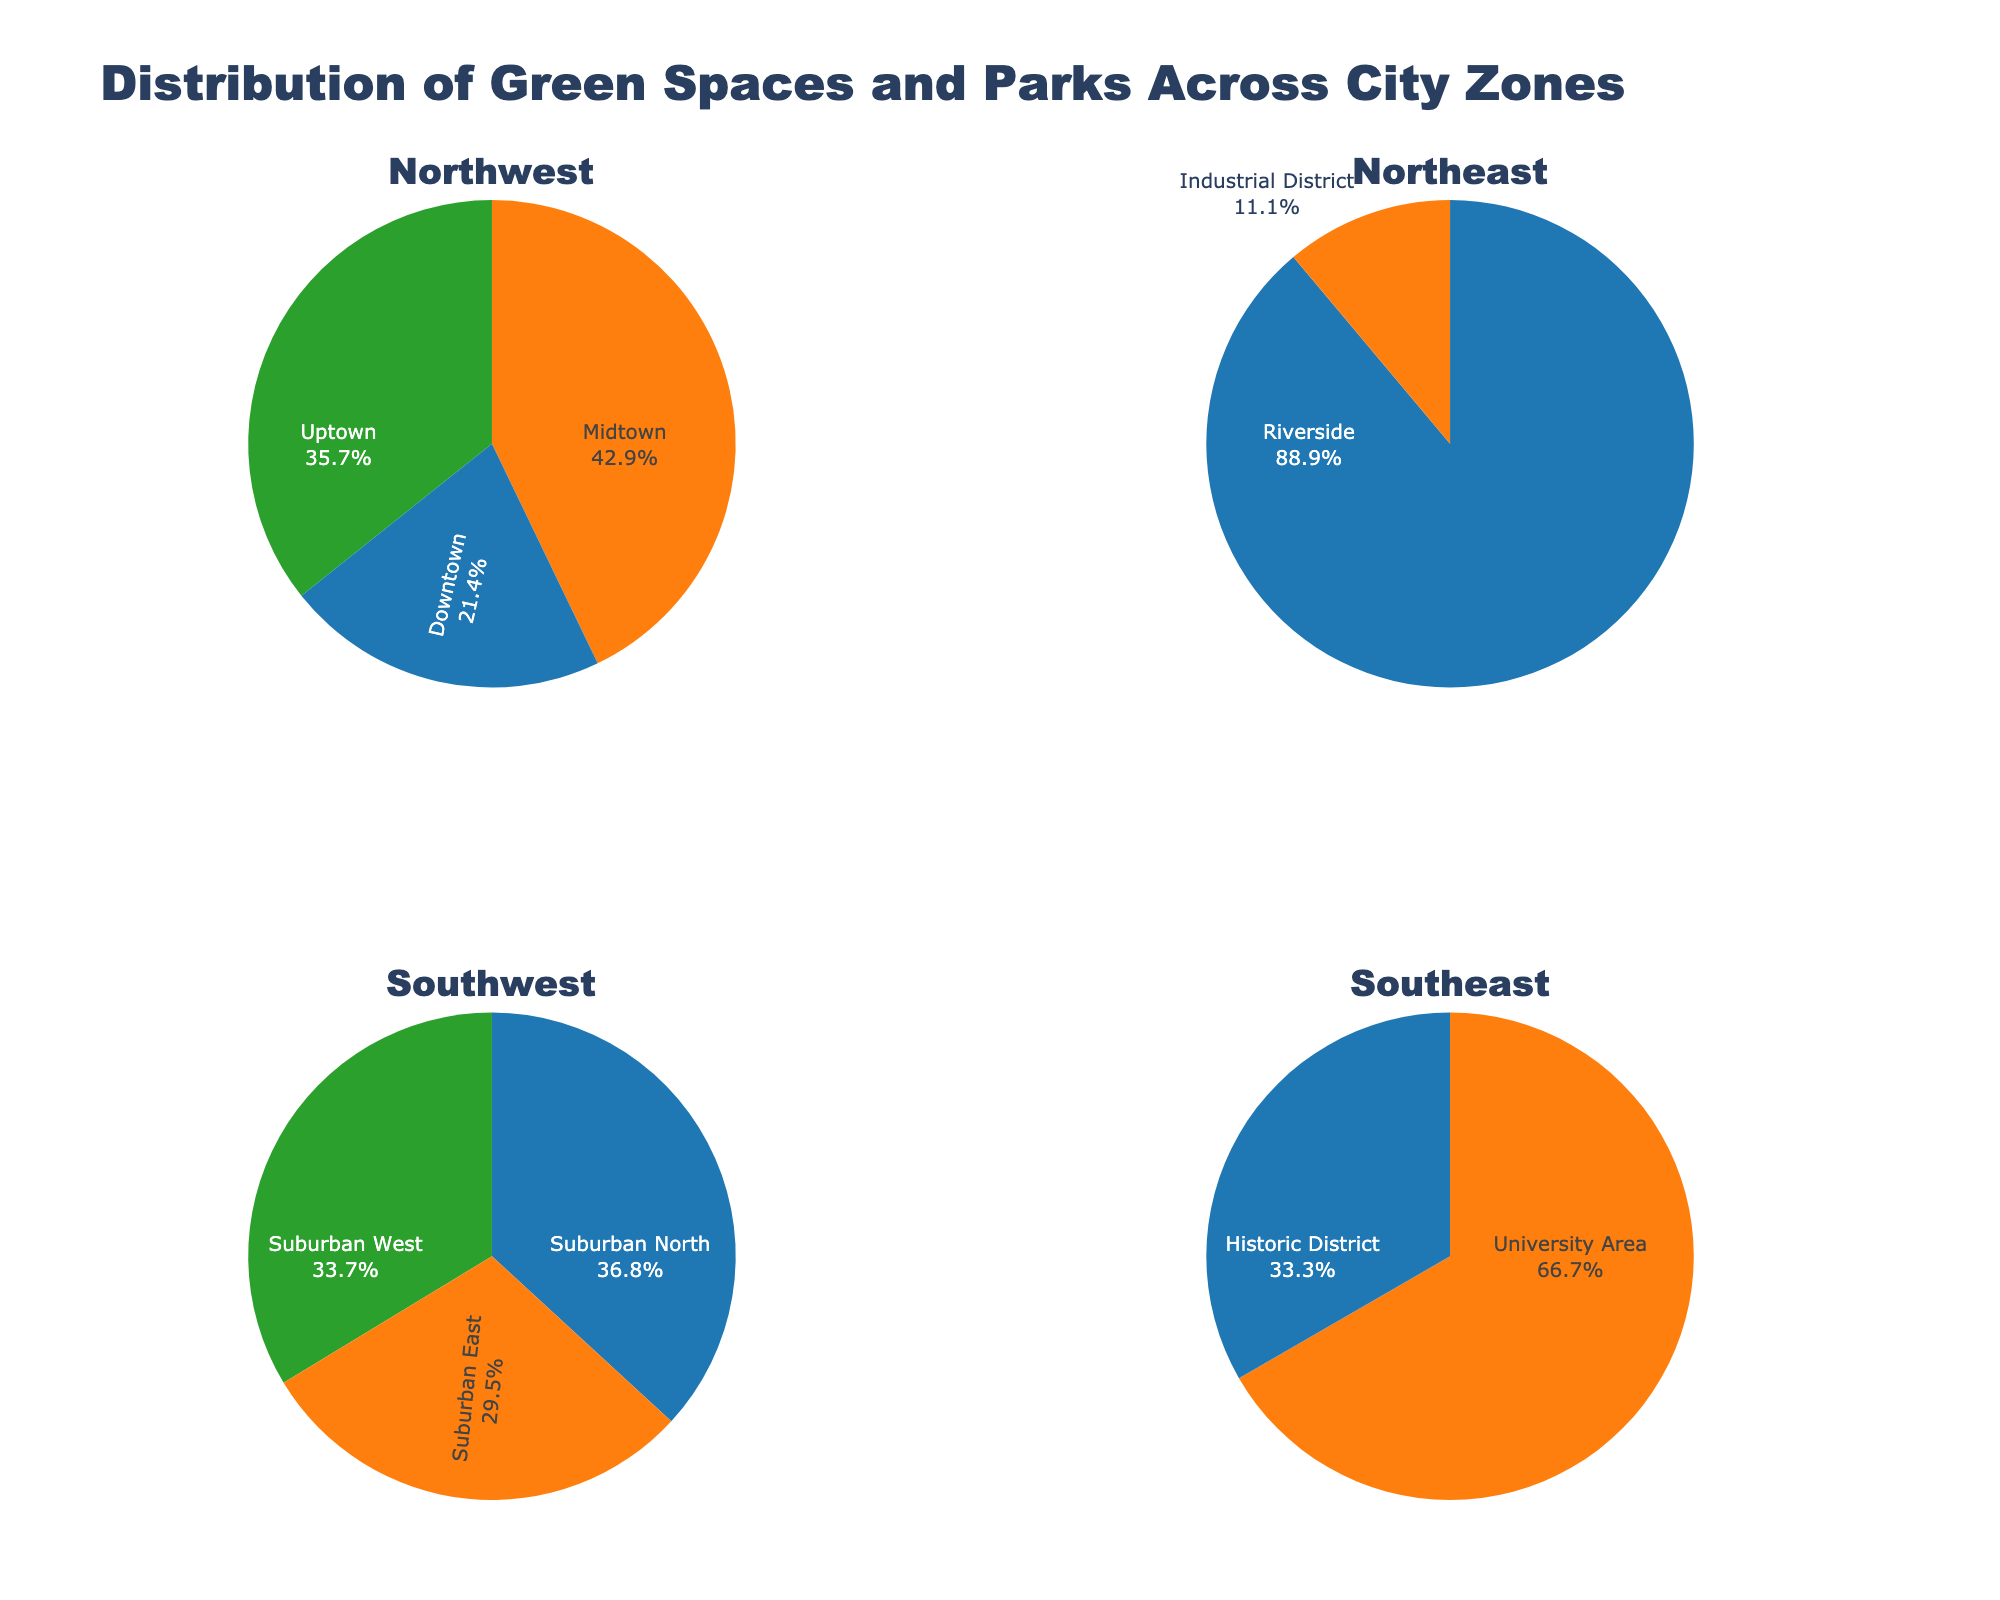What's the title of the figure? The title is located at the top of the figure in a large, bold font. It reads "Distribution of Green Spaces and Parks Across City Zones."
Answer: Distribution of Green Spaces and Parks Across City Zones In which subplot is the zone 'Riverside' located? Riverside is part of the first group, which corresponds to the first row, first column in the subplot grid labeled 'Northwest.'
Answer: Northwest How many zones are represented in the 'Southwest' subplot? Each group is sectioned into different subplots. The 'Southwest' subplot contains three zones: 'Suburban North,' 'Suburban East,' and 'Suburban West.'
Answer: 3 Which zone has the smallest park area, and in which subplot is it found? The Industrial District zone has the smallest park area of 5 hectares. It is found in the 'Northeast' subplot.
Answer: Industrial District in Northeast How does the park area of 'University Area' compare to 'Historic District'? 'University Area' has a park area of 20 hectares, while 'Historic District' has 10 hectares. Comparing these, 'University Area' has a larger park area.
Answer: University Area has more park area than Historic District Which zone contributes the most to the park area in the 'Northeast' subplot? The 'Riverside' zone has the largest park area in this subplot, encompassing 40 hectares.
Answer: Riverside What is the total park area represented in the 'Northwest' subplot? Adding the park areas of the three zones: Downtown (15), Midtown (30), and Uptown (25) results in a total of 70 hectares.
Answer: 70 hectares What percentage of the 'Southwest' subplot's total park area does 'Suburban West' contribute? 'Suburban West' has a park area of 32 hectares. The total park area for the 'Southwest' subplot (Suburban North: 35, Suburban East: 28, Suburban West: 32) is 95 hectares. (32/95)*100 = 33.7%.
Answer: 33.7% Which zone in the 'Southeast' subplot has the greater park area, and by how much more than the other? 'University Area' has 20 hectares, while 'Historic District' has 10 hectares. Therefore, it has 10 hectares more than the Historical District.
Answer: University Area by 10 hectares 